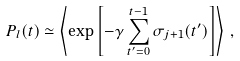Convert formula to latex. <formula><loc_0><loc_0><loc_500><loc_500>P _ { l } ( t ) \simeq \left \langle \exp \left [ - \gamma \sum _ { t ^ { \prime } = 0 } ^ { t - 1 } \sigma _ { j + 1 } ( t ^ { \prime } ) \right ] \right \rangle \, ,</formula> 